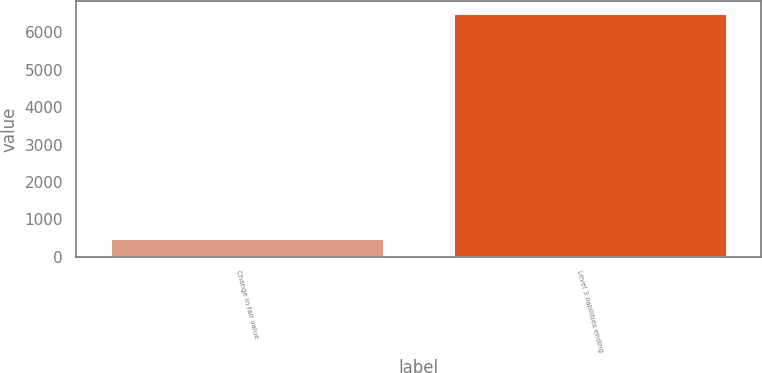Convert chart. <chart><loc_0><loc_0><loc_500><loc_500><bar_chart><fcel>Change in fair value<fcel>Level 3 liabilities ending<nl><fcel>510<fcel>6510<nl></chart> 